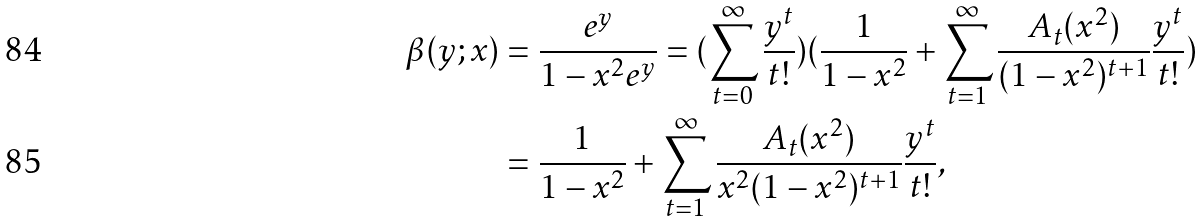Convert formula to latex. <formula><loc_0><loc_0><loc_500><loc_500>\beta ( y ; x ) & = \frac { e ^ { y } } { 1 - x ^ { 2 } e ^ { y } } = ( \sum _ { t = 0 } ^ { \infty } \frac { y ^ { t } } { t ! } ) ( \frac { 1 } { 1 - x ^ { 2 } } + \sum _ { t = 1 } ^ { \infty } \frac { A _ { t } ( x ^ { 2 } ) } { ( 1 - x ^ { 2 } ) ^ { t + 1 } } \frac { y ^ { t } } { t ! } ) \\ & = \frac { 1 } { 1 - x ^ { 2 } } + \sum _ { t = 1 } ^ { \infty } \frac { A _ { t } ( x ^ { 2 } ) } { x ^ { 2 } ( 1 - x ^ { 2 } ) ^ { t + 1 } } \frac { y ^ { t } } { t ! } ,</formula> 